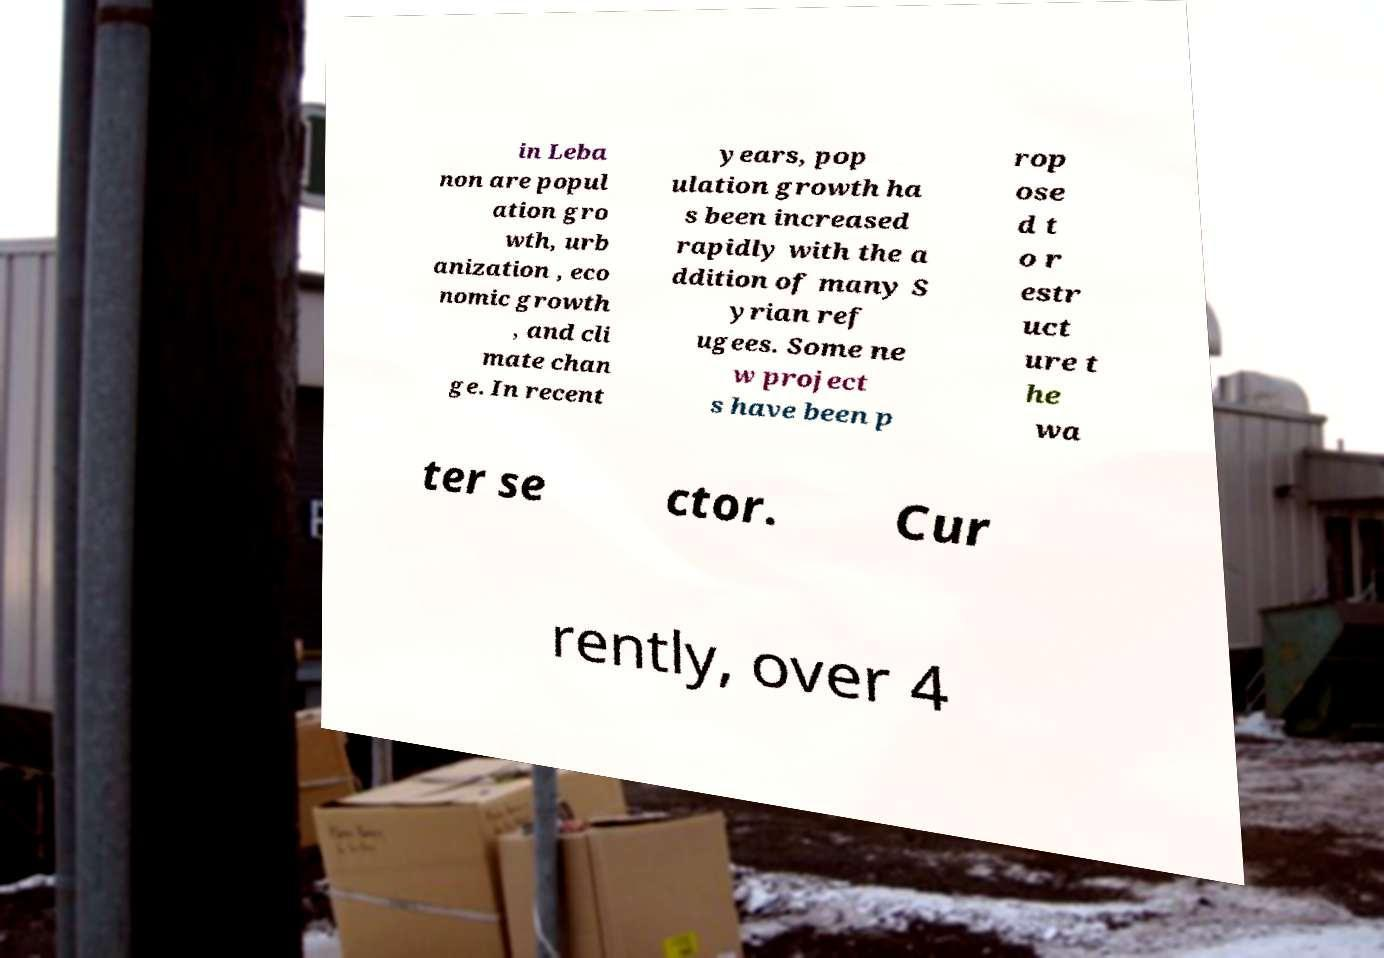Can you accurately transcribe the text from the provided image for me? in Leba non are popul ation gro wth, urb anization , eco nomic growth , and cli mate chan ge. In recent years, pop ulation growth ha s been increased rapidly with the a ddition of many S yrian ref ugees. Some ne w project s have been p rop ose d t o r estr uct ure t he wa ter se ctor. Cur rently, over 4 